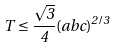Convert formula to latex. <formula><loc_0><loc_0><loc_500><loc_500>T \leq \frac { \sqrt { 3 } } { 4 } ( a b c ) ^ { 2 / 3 }</formula> 